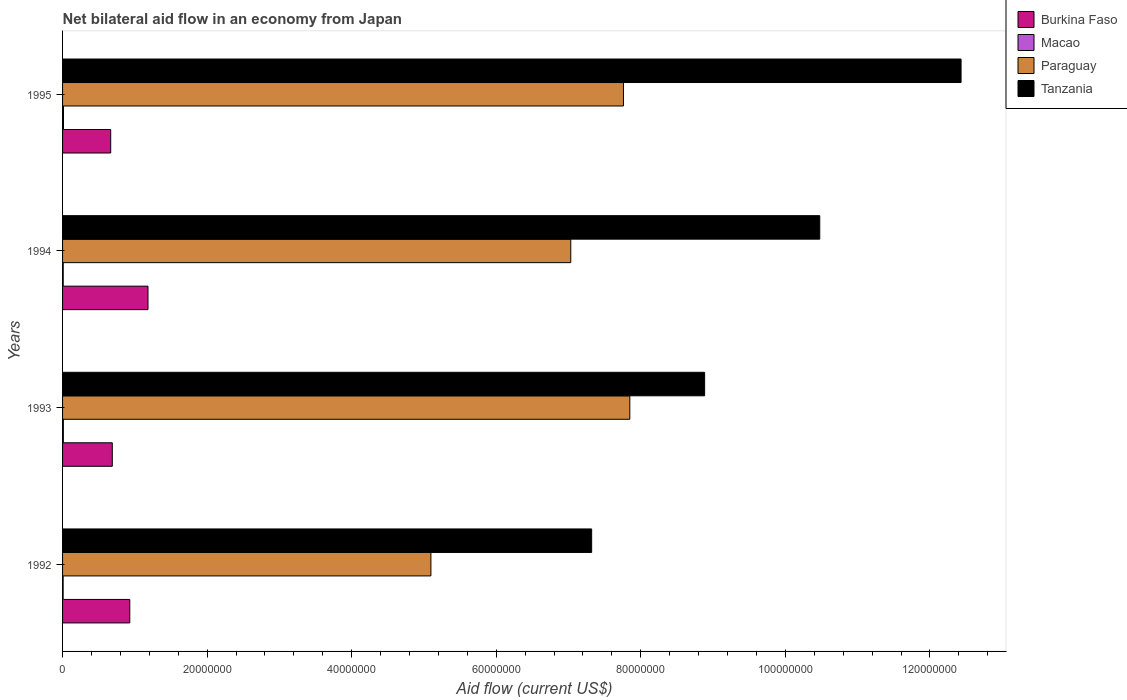Are the number of bars per tick equal to the number of legend labels?
Provide a short and direct response. Yes. Are the number of bars on each tick of the Y-axis equal?
Provide a succinct answer. Yes. How many bars are there on the 1st tick from the bottom?
Keep it short and to the point. 4. What is the net bilateral aid flow in Macao in 1994?
Make the answer very short. 9.00e+04. Across all years, what is the minimum net bilateral aid flow in Burkina Faso?
Provide a succinct answer. 6.66e+06. In which year was the net bilateral aid flow in Burkina Faso minimum?
Keep it short and to the point. 1995. What is the total net bilateral aid flow in Tanzania in the graph?
Offer a terse response. 3.91e+08. What is the difference between the net bilateral aid flow in Macao in 1992 and that in 1993?
Provide a succinct answer. -3.00e+04. What is the difference between the net bilateral aid flow in Macao in 1992 and the net bilateral aid flow in Tanzania in 1993?
Your response must be concise. -8.88e+07. What is the average net bilateral aid flow in Paraguay per year?
Your response must be concise. 6.93e+07. In the year 1992, what is the difference between the net bilateral aid flow in Paraguay and net bilateral aid flow in Burkina Faso?
Give a very brief answer. 4.17e+07. In how many years, is the net bilateral aid flow in Macao greater than 28000000 US$?
Offer a very short reply. 0. What is the ratio of the net bilateral aid flow in Paraguay in 1992 to that in 1993?
Provide a short and direct response. 0.65. What is the difference between the highest and the second highest net bilateral aid flow in Burkina Faso?
Give a very brief answer. 2.52e+06. What is the difference between the highest and the lowest net bilateral aid flow in Burkina Faso?
Your response must be concise. 5.16e+06. Is it the case that in every year, the sum of the net bilateral aid flow in Burkina Faso and net bilateral aid flow in Macao is greater than the sum of net bilateral aid flow in Paraguay and net bilateral aid flow in Tanzania?
Keep it short and to the point. No. What does the 4th bar from the top in 1993 represents?
Offer a terse response. Burkina Faso. What does the 2nd bar from the bottom in 1992 represents?
Offer a very short reply. Macao. Is it the case that in every year, the sum of the net bilateral aid flow in Macao and net bilateral aid flow in Burkina Faso is greater than the net bilateral aid flow in Paraguay?
Provide a succinct answer. No. How many bars are there?
Make the answer very short. 16. Are all the bars in the graph horizontal?
Offer a very short reply. Yes. Does the graph contain any zero values?
Ensure brevity in your answer.  No. How many legend labels are there?
Your answer should be compact. 4. What is the title of the graph?
Provide a short and direct response. Net bilateral aid flow in an economy from Japan. Does "Austria" appear as one of the legend labels in the graph?
Give a very brief answer. No. What is the label or title of the X-axis?
Make the answer very short. Aid flow (current US$). What is the label or title of the Y-axis?
Provide a succinct answer. Years. What is the Aid flow (current US$) in Burkina Faso in 1992?
Your response must be concise. 9.30e+06. What is the Aid flow (current US$) in Paraguay in 1992?
Provide a short and direct response. 5.10e+07. What is the Aid flow (current US$) of Tanzania in 1992?
Your answer should be very brief. 7.32e+07. What is the Aid flow (current US$) in Burkina Faso in 1993?
Your answer should be compact. 6.88e+06. What is the Aid flow (current US$) in Macao in 1993?
Make the answer very short. 1.10e+05. What is the Aid flow (current US$) in Paraguay in 1993?
Make the answer very short. 7.85e+07. What is the Aid flow (current US$) in Tanzania in 1993?
Offer a very short reply. 8.88e+07. What is the Aid flow (current US$) of Burkina Faso in 1994?
Ensure brevity in your answer.  1.18e+07. What is the Aid flow (current US$) in Paraguay in 1994?
Provide a short and direct response. 7.03e+07. What is the Aid flow (current US$) in Tanzania in 1994?
Give a very brief answer. 1.05e+08. What is the Aid flow (current US$) of Burkina Faso in 1995?
Ensure brevity in your answer.  6.66e+06. What is the Aid flow (current US$) of Paraguay in 1995?
Your response must be concise. 7.76e+07. What is the Aid flow (current US$) of Tanzania in 1995?
Your response must be concise. 1.24e+08. Across all years, what is the maximum Aid flow (current US$) of Burkina Faso?
Provide a succinct answer. 1.18e+07. Across all years, what is the maximum Aid flow (current US$) of Paraguay?
Give a very brief answer. 7.85e+07. Across all years, what is the maximum Aid flow (current US$) of Tanzania?
Offer a terse response. 1.24e+08. Across all years, what is the minimum Aid flow (current US$) of Burkina Faso?
Make the answer very short. 6.66e+06. Across all years, what is the minimum Aid flow (current US$) in Paraguay?
Offer a very short reply. 5.10e+07. Across all years, what is the minimum Aid flow (current US$) of Tanzania?
Provide a short and direct response. 7.32e+07. What is the total Aid flow (current US$) of Burkina Faso in the graph?
Offer a very short reply. 3.47e+07. What is the total Aid flow (current US$) in Macao in the graph?
Give a very brief answer. 4.10e+05. What is the total Aid flow (current US$) of Paraguay in the graph?
Provide a succinct answer. 2.77e+08. What is the total Aid flow (current US$) of Tanzania in the graph?
Provide a short and direct response. 3.91e+08. What is the difference between the Aid flow (current US$) of Burkina Faso in 1992 and that in 1993?
Give a very brief answer. 2.42e+06. What is the difference between the Aid flow (current US$) of Paraguay in 1992 and that in 1993?
Give a very brief answer. -2.75e+07. What is the difference between the Aid flow (current US$) of Tanzania in 1992 and that in 1993?
Make the answer very short. -1.56e+07. What is the difference between the Aid flow (current US$) in Burkina Faso in 1992 and that in 1994?
Offer a terse response. -2.52e+06. What is the difference between the Aid flow (current US$) of Paraguay in 1992 and that in 1994?
Ensure brevity in your answer.  -1.94e+07. What is the difference between the Aid flow (current US$) in Tanzania in 1992 and that in 1994?
Offer a terse response. -3.16e+07. What is the difference between the Aid flow (current US$) in Burkina Faso in 1992 and that in 1995?
Offer a very short reply. 2.64e+06. What is the difference between the Aid flow (current US$) in Macao in 1992 and that in 1995?
Your response must be concise. -5.00e+04. What is the difference between the Aid flow (current US$) in Paraguay in 1992 and that in 1995?
Keep it short and to the point. -2.66e+07. What is the difference between the Aid flow (current US$) in Tanzania in 1992 and that in 1995?
Give a very brief answer. -5.11e+07. What is the difference between the Aid flow (current US$) of Burkina Faso in 1993 and that in 1994?
Your answer should be very brief. -4.94e+06. What is the difference between the Aid flow (current US$) of Paraguay in 1993 and that in 1994?
Your answer should be compact. 8.17e+06. What is the difference between the Aid flow (current US$) in Tanzania in 1993 and that in 1994?
Offer a terse response. -1.59e+07. What is the difference between the Aid flow (current US$) of Burkina Faso in 1993 and that in 1995?
Ensure brevity in your answer.  2.20e+05. What is the difference between the Aid flow (current US$) in Macao in 1993 and that in 1995?
Your answer should be compact. -2.00e+04. What is the difference between the Aid flow (current US$) of Paraguay in 1993 and that in 1995?
Ensure brevity in your answer.  8.80e+05. What is the difference between the Aid flow (current US$) of Tanzania in 1993 and that in 1995?
Provide a succinct answer. -3.55e+07. What is the difference between the Aid flow (current US$) of Burkina Faso in 1994 and that in 1995?
Your answer should be very brief. 5.16e+06. What is the difference between the Aid flow (current US$) of Macao in 1994 and that in 1995?
Offer a very short reply. -4.00e+04. What is the difference between the Aid flow (current US$) of Paraguay in 1994 and that in 1995?
Keep it short and to the point. -7.29e+06. What is the difference between the Aid flow (current US$) in Tanzania in 1994 and that in 1995?
Ensure brevity in your answer.  -1.96e+07. What is the difference between the Aid flow (current US$) in Burkina Faso in 1992 and the Aid flow (current US$) in Macao in 1993?
Offer a very short reply. 9.19e+06. What is the difference between the Aid flow (current US$) of Burkina Faso in 1992 and the Aid flow (current US$) of Paraguay in 1993?
Give a very brief answer. -6.92e+07. What is the difference between the Aid flow (current US$) of Burkina Faso in 1992 and the Aid flow (current US$) of Tanzania in 1993?
Make the answer very short. -7.95e+07. What is the difference between the Aid flow (current US$) of Macao in 1992 and the Aid flow (current US$) of Paraguay in 1993?
Ensure brevity in your answer.  -7.84e+07. What is the difference between the Aid flow (current US$) of Macao in 1992 and the Aid flow (current US$) of Tanzania in 1993?
Give a very brief answer. -8.88e+07. What is the difference between the Aid flow (current US$) of Paraguay in 1992 and the Aid flow (current US$) of Tanzania in 1993?
Your answer should be very brief. -3.79e+07. What is the difference between the Aid flow (current US$) in Burkina Faso in 1992 and the Aid flow (current US$) in Macao in 1994?
Keep it short and to the point. 9.21e+06. What is the difference between the Aid flow (current US$) of Burkina Faso in 1992 and the Aid flow (current US$) of Paraguay in 1994?
Ensure brevity in your answer.  -6.10e+07. What is the difference between the Aid flow (current US$) of Burkina Faso in 1992 and the Aid flow (current US$) of Tanzania in 1994?
Provide a short and direct response. -9.55e+07. What is the difference between the Aid flow (current US$) in Macao in 1992 and the Aid flow (current US$) in Paraguay in 1994?
Make the answer very short. -7.02e+07. What is the difference between the Aid flow (current US$) of Macao in 1992 and the Aid flow (current US$) of Tanzania in 1994?
Provide a short and direct response. -1.05e+08. What is the difference between the Aid flow (current US$) of Paraguay in 1992 and the Aid flow (current US$) of Tanzania in 1994?
Offer a very short reply. -5.38e+07. What is the difference between the Aid flow (current US$) of Burkina Faso in 1992 and the Aid flow (current US$) of Macao in 1995?
Offer a terse response. 9.17e+06. What is the difference between the Aid flow (current US$) of Burkina Faso in 1992 and the Aid flow (current US$) of Paraguay in 1995?
Offer a terse response. -6.83e+07. What is the difference between the Aid flow (current US$) in Burkina Faso in 1992 and the Aid flow (current US$) in Tanzania in 1995?
Your answer should be compact. -1.15e+08. What is the difference between the Aid flow (current US$) in Macao in 1992 and the Aid flow (current US$) in Paraguay in 1995?
Your answer should be compact. -7.75e+07. What is the difference between the Aid flow (current US$) of Macao in 1992 and the Aid flow (current US$) of Tanzania in 1995?
Give a very brief answer. -1.24e+08. What is the difference between the Aid flow (current US$) of Paraguay in 1992 and the Aid flow (current US$) of Tanzania in 1995?
Give a very brief answer. -7.34e+07. What is the difference between the Aid flow (current US$) of Burkina Faso in 1993 and the Aid flow (current US$) of Macao in 1994?
Give a very brief answer. 6.79e+06. What is the difference between the Aid flow (current US$) in Burkina Faso in 1993 and the Aid flow (current US$) in Paraguay in 1994?
Your answer should be compact. -6.34e+07. What is the difference between the Aid flow (current US$) of Burkina Faso in 1993 and the Aid flow (current US$) of Tanzania in 1994?
Your answer should be very brief. -9.79e+07. What is the difference between the Aid flow (current US$) in Macao in 1993 and the Aid flow (current US$) in Paraguay in 1994?
Offer a very short reply. -7.02e+07. What is the difference between the Aid flow (current US$) in Macao in 1993 and the Aid flow (current US$) in Tanzania in 1994?
Ensure brevity in your answer.  -1.05e+08. What is the difference between the Aid flow (current US$) of Paraguay in 1993 and the Aid flow (current US$) of Tanzania in 1994?
Offer a very short reply. -2.63e+07. What is the difference between the Aid flow (current US$) in Burkina Faso in 1993 and the Aid flow (current US$) in Macao in 1995?
Your answer should be compact. 6.75e+06. What is the difference between the Aid flow (current US$) of Burkina Faso in 1993 and the Aid flow (current US$) of Paraguay in 1995?
Give a very brief answer. -7.07e+07. What is the difference between the Aid flow (current US$) of Burkina Faso in 1993 and the Aid flow (current US$) of Tanzania in 1995?
Ensure brevity in your answer.  -1.17e+08. What is the difference between the Aid flow (current US$) of Macao in 1993 and the Aid flow (current US$) of Paraguay in 1995?
Offer a very short reply. -7.75e+07. What is the difference between the Aid flow (current US$) in Macao in 1993 and the Aid flow (current US$) in Tanzania in 1995?
Ensure brevity in your answer.  -1.24e+08. What is the difference between the Aid flow (current US$) of Paraguay in 1993 and the Aid flow (current US$) of Tanzania in 1995?
Your answer should be compact. -4.58e+07. What is the difference between the Aid flow (current US$) of Burkina Faso in 1994 and the Aid flow (current US$) of Macao in 1995?
Keep it short and to the point. 1.17e+07. What is the difference between the Aid flow (current US$) in Burkina Faso in 1994 and the Aid flow (current US$) in Paraguay in 1995?
Your answer should be compact. -6.58e+07. What is the difference between the Aid flow (current US$) in Burkina Faso in 1994 and the Aid flow (current US$) in Tanzania in 1995?
Ensure brevity in your answer.  -1.12e+08. What is the difference between the Aid flow (current US$) in Macao in 1994 and the Aid flow (current US$) in Paraguay in 1995?
Your answer should be compact. -7.75e+07. What is the difference between the Aid flow (current US$) in Macao in 1994 and the Aid flow (current US$) in Tanzania in 1995?
Give a very brief answer. -1.24e+08. What is the difference between the Aid flow (current US$) in Paraguay in 1994 and the Aid flow (current US$) in Tanzania in 1995?
Give a very brief answer. -5.40e+07. What is the average Aid flow (current US$) of Burkina Faso per year?
Ensure brevity in your answer.  8.66e+06. What is the average Aid flow (current US$) of Macao per year?
Your answer should be very brief. 1.02e+05. What is the average Aid flow (current US$) of Paraguay per year?
Provide a short and direct response. 6.93e+07. What is the average Aid flow (current US$) of Tanzania per year?
Keep it short and to the point. 9.78e+07. In the year 1992, what is the difference between the Aid flow (current US$) of Burkina Faso and Aid flow (current US$) of Macao?
Your response must be concise. 9.22e+06. In the year 1992, what is the difference between the Aid flow (current US$) of Burkina Faso and Aid flow (current US$) of Paraguay?
Provide a short and direct response. -4.17e+07. In the year 1992, what is the difference between the Aid flow (current US$) of Burkina Faso and Aid flow (current US$) of Tanzania?
Provide a succinct answer. -6.39e+07. In the year 1992, what is the difference between the Aid flow (current US$) in Macao and Aid flow (current US$) in Paraguay?
Give a very brief answer. -5.09e+07. In the year 1992, what is the difference between the Aid flow (current US$) of Macao and Aid flow (current US$) of Tanzania?
Make the answer very short. -7.31e+07. In the year 1992, what is the difference between the Aid flow (current US$) in Paraguay and Aid flow (current US$) in Tanzania?
Your answer should be compact. -2.22e+07. In the year 1993, what is the difference between the Aid flow (current US$) in Burkina Faso and Aid flow (current US$) in Macao?
Make the answer very short. 6.77e+06. In the year 1993, what is the difference between the Aid flow (current US$) in Burkina Faso and Aid flow (current US$) in Paraguay?
Your answer should be very brief. -7.16e+07. In the year 1993, what is the difference between the Aid flow (current US$) in Burkina Faso and Aid flow (current US$) in Tanzania?
Keep it short and to the point. -8.20e+07. In the year 1993, what is the difference between the Aid flow (current US$) of Macao and Aid flow (current US$) of Paraguay?
Ensure brevity in your answer.  -7.84e+07. In the year 1993, what is the difference between the Aid flow (current US$) of Macao and Aid flow (current US$) of Tanzania?
Offer a very short reply. -8.87e+07. In the year 1993, what is the difference between the Aid flow (current US$) of Paraguay and Aid flow (current US$) of Tanzania?
Provide a short and direct response. -1.04e+07. In the year 1994, what is the difference between the Aid flow (current US$) in Burkina Faso and Aid flow (current US$) in Macao?
Your answer should be very brief. 1.17e+07. In the year 1994, what is the difference between the Aid flow (current US$) in Burkina Faso and Aid flow (current US$) in Paraguay?
Your answer should be compact. -5.85e+07. In the year 1994, what is the difference between the Aid flow (current US$) of Burkina Faso and Aid flow (current US$) of Tanzania?
Your response must be concise. -9.29e+07. In the year 1994, what is the difference between the Aid flow (current US$) of Macao and Aid flow (current US$) of Paraguay?
Your response must be concise. -7.02e+07. In the year 1994, what is the difference between the Aid flow (current US$) of Macao and Aid flow (current US$) of Tanzania?
Provide a short and direct response. -1.05e+08. In the year 1994, what is the difference between the Aid flow (current US$) in Paraguay and Aid flow (current US$) in Tanzania?
Give a very brief answer. -3.44e+07. In the year 1995, what is the difference between the Aid flow (current US$) in Burkina Faso and Aid flow (current US$) in Macao?
Make the answer very short. 6.53e+06. In the year 1995, what is the difference between the Aid flow (current US$) in Burkina Faso and Aid flow (current US$) in Paraguay?
Your answer should be compact. -7.09e+07. In the year 1995, what is the difference between the Aid flow (current US$) in Burkina Faso and Aid flow (current US$) in Tanzania?
Make the answer very short. -1.18e+08. In the year 1995, what is the difference between the Aid flow (current US$) of Macao and Aid flow (current US$) of Paraguay?
Your answer should be compact. -7.75e+07. In the year 1995, what is the difference between the Aid flow (current US$) of Macao and Aid flow (current US$) of Tanzania?
Your answer should be very brief. -1.24e+08. In the year 1995, what is the difference between the Aid flow (current US$) of Paraguay and Aid flow (current US$) of Tanzania?
Keep it short and to the point. -4.67e+07. What is the ratio of the Aid flow (current US$) in Burkina Faso in 1992 to that in 1993?
Ensure brevity in your answer.  1.35. What is the ratio of the Aid flow (current US$) in Macao in 1992 to that in 1993?
Give a very brief answer. 0.73. What is the ratio of the Aid flow (current US$) of Paraguay in 1992 to that in 1993?
Provide a short and direct response. 0.65. What is the ratio of the Aid flow (current US$) of Tanzania in 1992 to that in 1993?
Offer a very short reply. 0.82. What is the ratio of the Aid flow (current US$) in Burkina Faso in 1992 to that in 1994?
Provide a short and direct response. 0.79. What is the ratio of the Aid flow (current US$) in Paraguay in 1992 to that in 1994?
Give a very brief answer. 0.72. What is the ratio of the Aid flow (current US$) of Tanzania in 1992 to that in 1994?
Provide a short and direct response. 0.7. What is the ratio of the Aid flow (current US$) in Burkina Faso in 1992 to that in 1995?
Provide a succinct answer. 1.4. What is the ratio of the Aid flow (current US$) of Macao in 1992 to that in 1995?
Your response must be concise. 0.62. What is the ratio of the Aid flow (current US$) of Paraguay in 1992 to that in 1995?
Offer a very short reply. 0.66. What is the ratio of the Aid flow (current US$) in Tanzania in 1992 to that in 1995?
Your answer should be very brief. 0.59. What is the ratio of the Aid flow (current US$) in Burkina Faso in 1993 to that in 1994?
Offer a very short reply. 0.58. What is the ratio of the Aid flow (current US$) of Macao in 1993 to that in 1994?
Offer a very short reply. 1.22. What is the ratio of the Aid flow (current US$) in Paraguay in 1993 to that in 1994?
Provide a short and direct response. 1.12. What is the ratio of the Aid flow (current US$) of Tanzania in 1993 to that in 1994?
Your response must be concise. 0.85. What is the ratio of the Aid flow (current US$) of Burkina Faso in 1993 to that in 1995?
Make the answer very short. 1.03. What is the ratio of the Aid flow (current US$) of Macao in 1993 to that in 1995?
Make the answer very short. 0.85. What is the ratio of the Aid flow (current US$) in Paraguay in 1993 to that in 1995?
Your response must be concise. 1.01. What is the ratio of the Aid flow (current US$) in Tanzania in 1993 to that in 1995?
Make the answer very short. 0.71. What is the ratio of the Aid flow (current US$) of Burkina Faso in 1994 to that in 1995?
Your response must be concise. 1.77. What is the ratio of the Aid flow (current US$) in Macao in 1994 to that in 1995?
Your response must be concise. 0.69. What is the ratio of the Aid flow (current US$) of Paraguay in 1994 to that in 1995?
Ensure brevity in your answer.  0.91. What is the ratio of the Aid flow (current US$) in Tanzania in 1994 to that in 1995?
Your answer should be compact. 0.84. What is the difference between the highest and the second highest Aid flow (current US$) of Burkina Faso?
Provide a short and direct response. 2.52e+06. What is the difference between the highest and the second highest Aid flow (current US$) of Paraguay?
Give a very brief answer. 8.80e+05. What is the difference between the highest and the second highest Aid flow (current US$) in Tanzania?
Provide a short and direct response. 1.96e+07. What is the difference between the highest and the lowest Aid flow (current US$) of Burkina Faso?
Give a very brief answer. 5.16e+06. What is the difference between the highest and the lowest Aid flow (current US$) of Macao?
Provide a short and direct response. 5.00e+04. What is the difference between the highest and the lowest Aid flow (current US$) of Paraguay?
Your answer should be compact. 2.75e+07. What is the difference between the highest and the lowest Aid flow (current US$) in Tanzania?
Provide a short and direct response. 5.11e+07. 